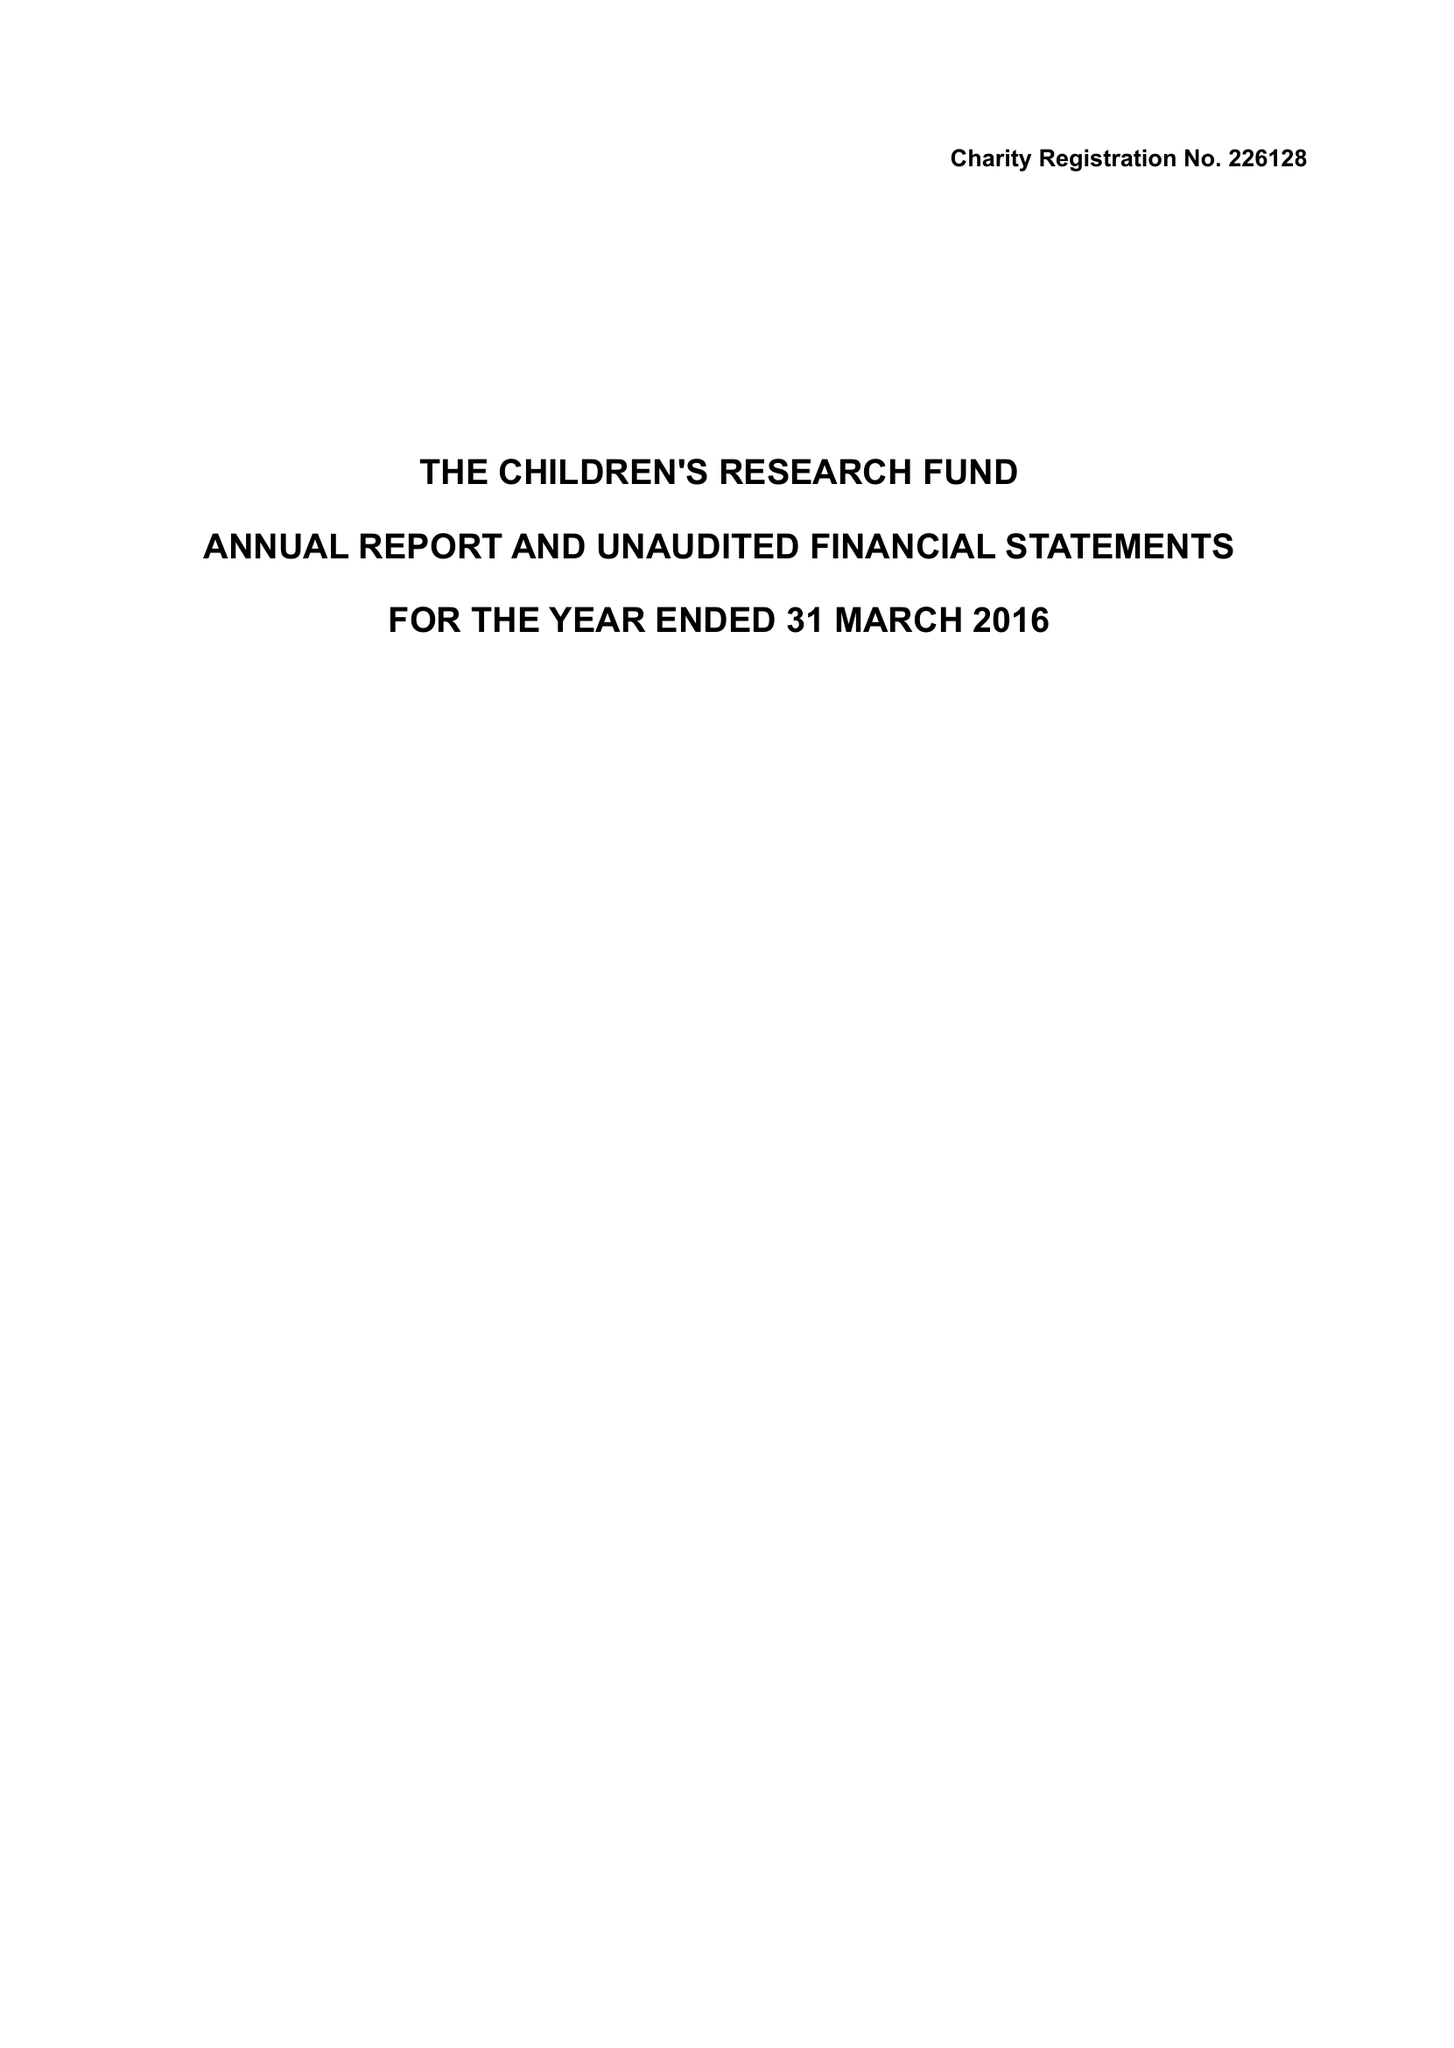What is the value for the address__postcode?
Answer the question using a single word or phrase. LL15 1AQ 